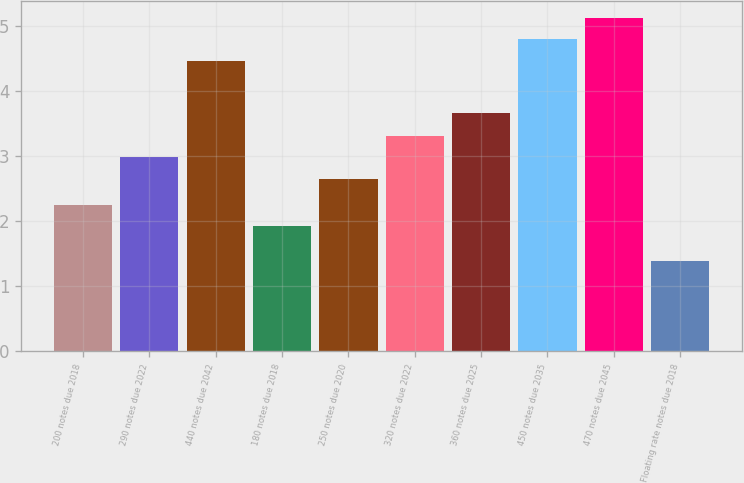Convert chart. <chart><loc_0><loc_0><loc_500><loc_500><bar_chart><fcel>200 notes due 2018<fcel>290 notes due 2022<fcel>440 notes due 2042<fcel>180 notes due 2018<fcel>250 notes due 2020<fcel>320 notes due 2022<fcel>360 notes due 2025<fcel>450 notes due 2035<fcel>470 notes due 2045<fcel>Floating rate notes due 2018<nl><fcel>2.25<fcel>2.98<fcel>4.46<fcel>1.92<fcel>2.65<fcel>3.31<fcel>3.66<fcel>4.79<fcel>5.12<fcel>1.38<nl></chart> 